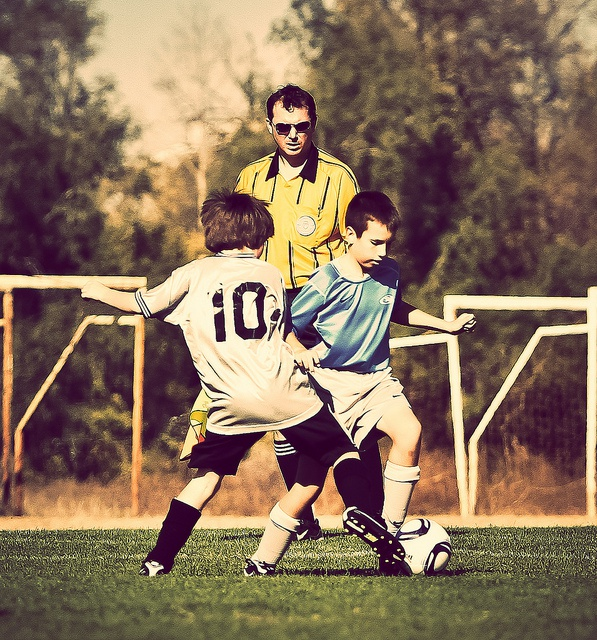Describe the objects in this image and their specific colors. I can see people in black, purple, beige, and tan tones, people in black, khaki, beige, purple, and navy tones, people in black, khaki, gold, and maroon tones, and sports ball in black, beige, tan, and gray tones in this image. 